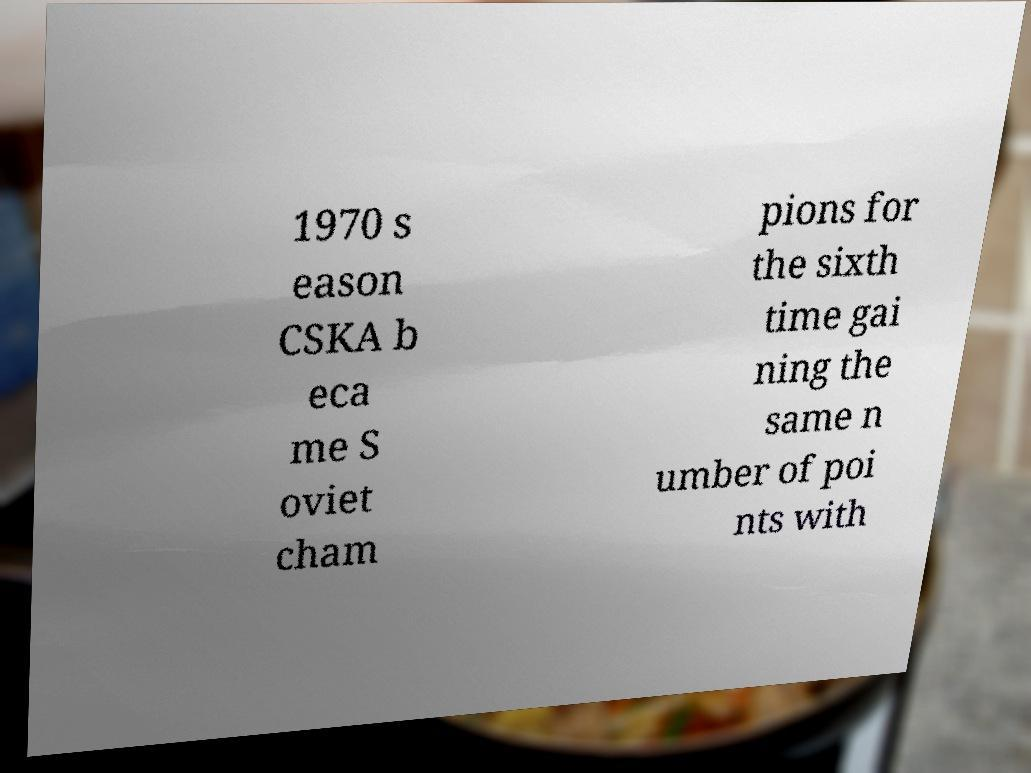Can you read and provide the text displayed in the image?This photo seems to have some interesting text. Can you extract and type it out for me? 1970 s eason CSKA b eca me S oviet cham pions for the sixth time gai ning the same n umber of poi nts with 